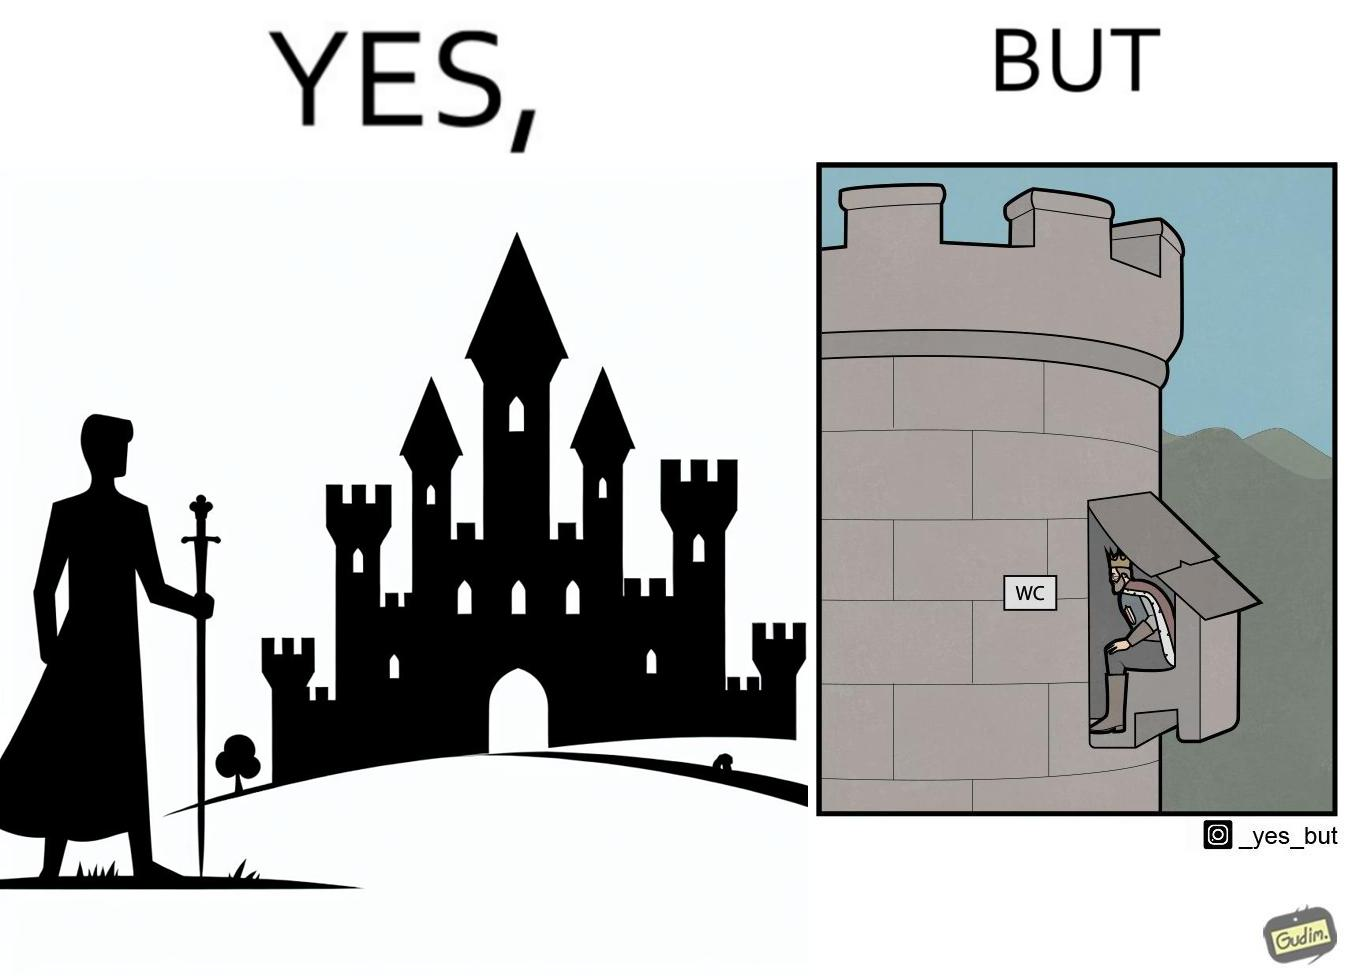Is there satirical content in this image? Yes, this image is satirical. 